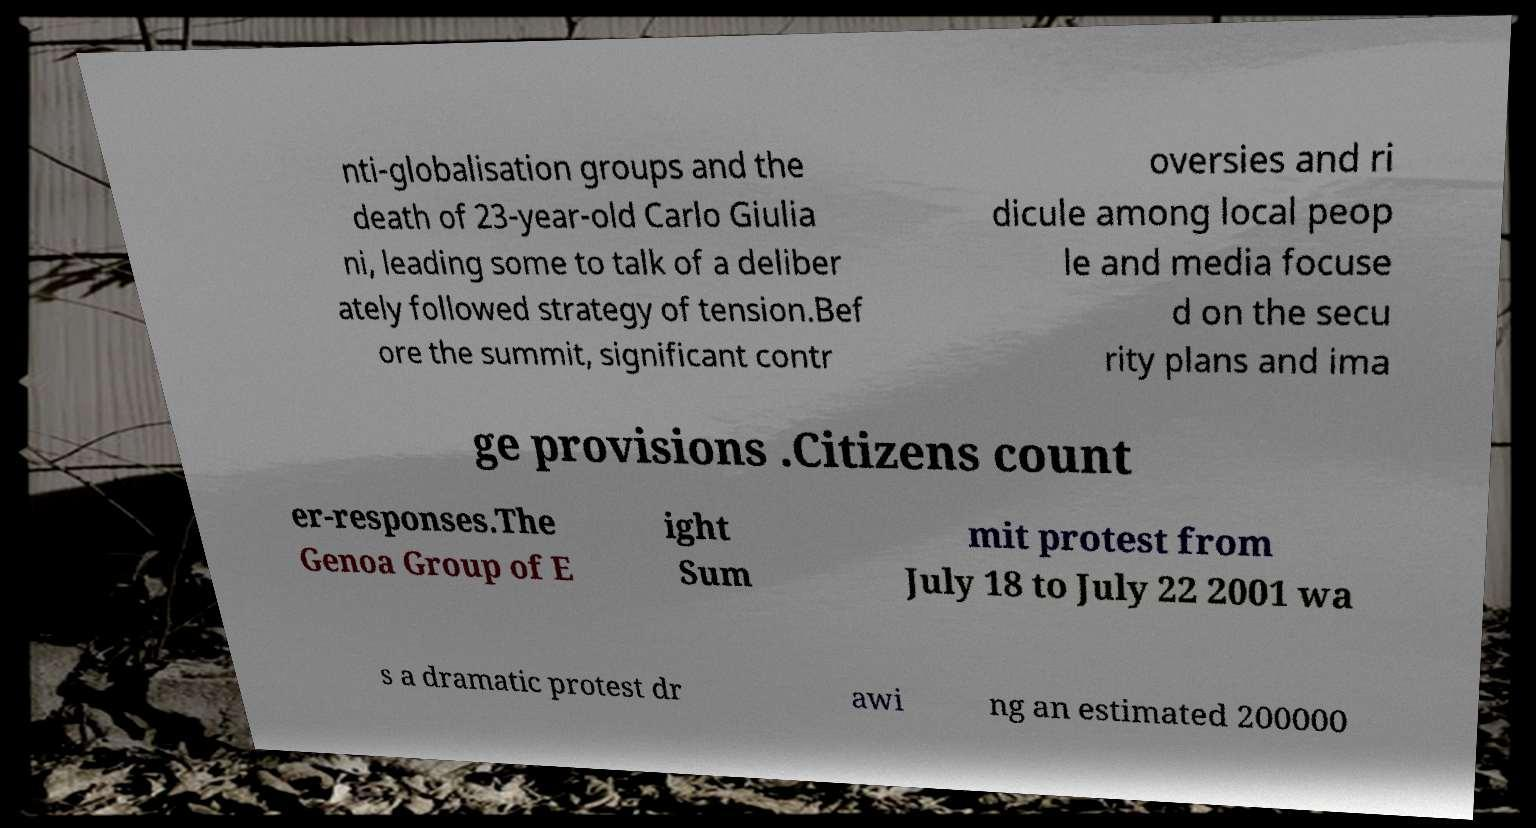Please read and relay the text visible in this image. What does it say? nti-globalisation groups and the death of 23-year-old Carlo Giulia ni, leading some to talk of a deliber ately followed strategy of tension.Bef ore the summit, significant contr oversies and ri dicule among local peop le and media focuse d on the secu rity plans and ima ge provisions .Citizens count er-responses.The Genoa Group of E ight Sum mit protest from July 18 to July 22 2001 wa s a dramatic protest dr awi ng an estimated 200000 